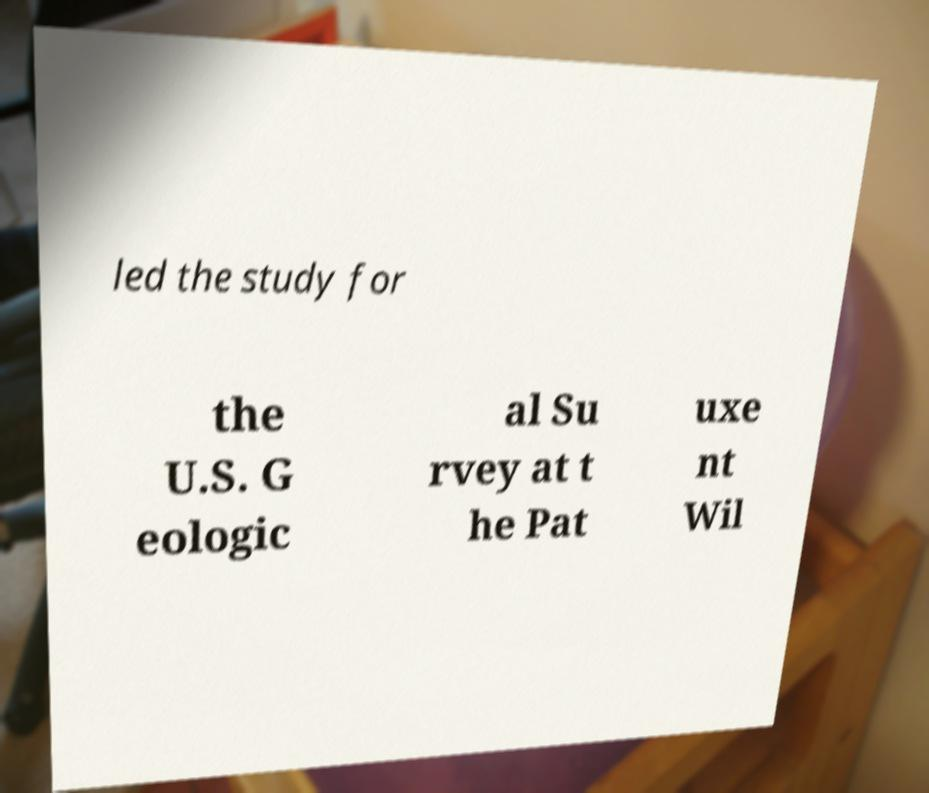There's text embedded in this image that I need extracted. Can you transcribe it verbatim? led the study for the U.S. G eologic al Su rvey at t he Pat uxe nt Wil 